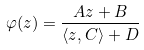Convert formula to latex. <formula><loc_0><loc_0><loc_500><loc_500>\varphi ( z ) = \frac { A z + B } { \langle z , C \rangle + D }</formula> 